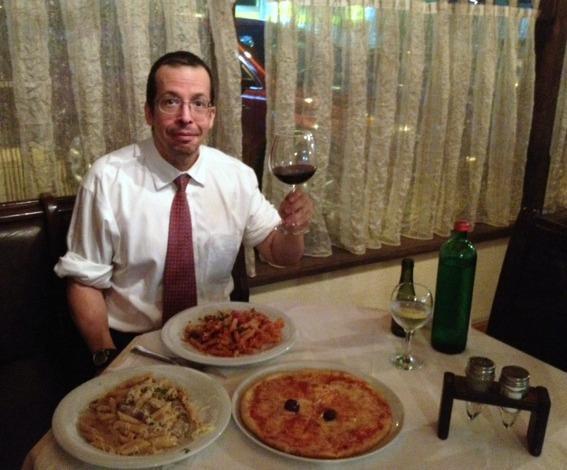Who does the person most look like?
Select the correct answer and articulate reasoning with the following format: 'Answer: answer
Rationale: rationale.'
Options: Tim duncan, maria sharapova, rick moranis, serena williams. Answer: rick moranis.
Rationale: Rick moranis always wears this facial expression. 